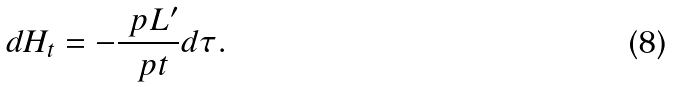Convert formula to latex. <formula><loc_0><loc_0><loc_500><loc_500>d H _ { t } = - \frac { \ p L ^ { \prime } } { \ p t } d \tau .</formula> 